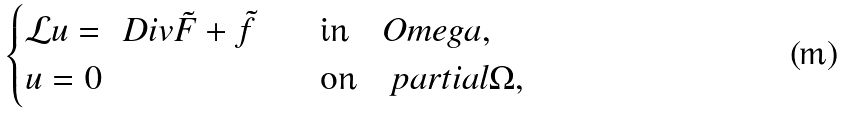<formula> <loc_0><loc_0><loc_500><loc_500>\begin{cases} \mathcal { L } u = \ D i v \tilde { F } + \tilde { f } \quad & \text {in} \quad O m e g a , \\ u = 0 \quad & \text {on} \quad p a r t i a l \Omega , \end{cases}</formula> 